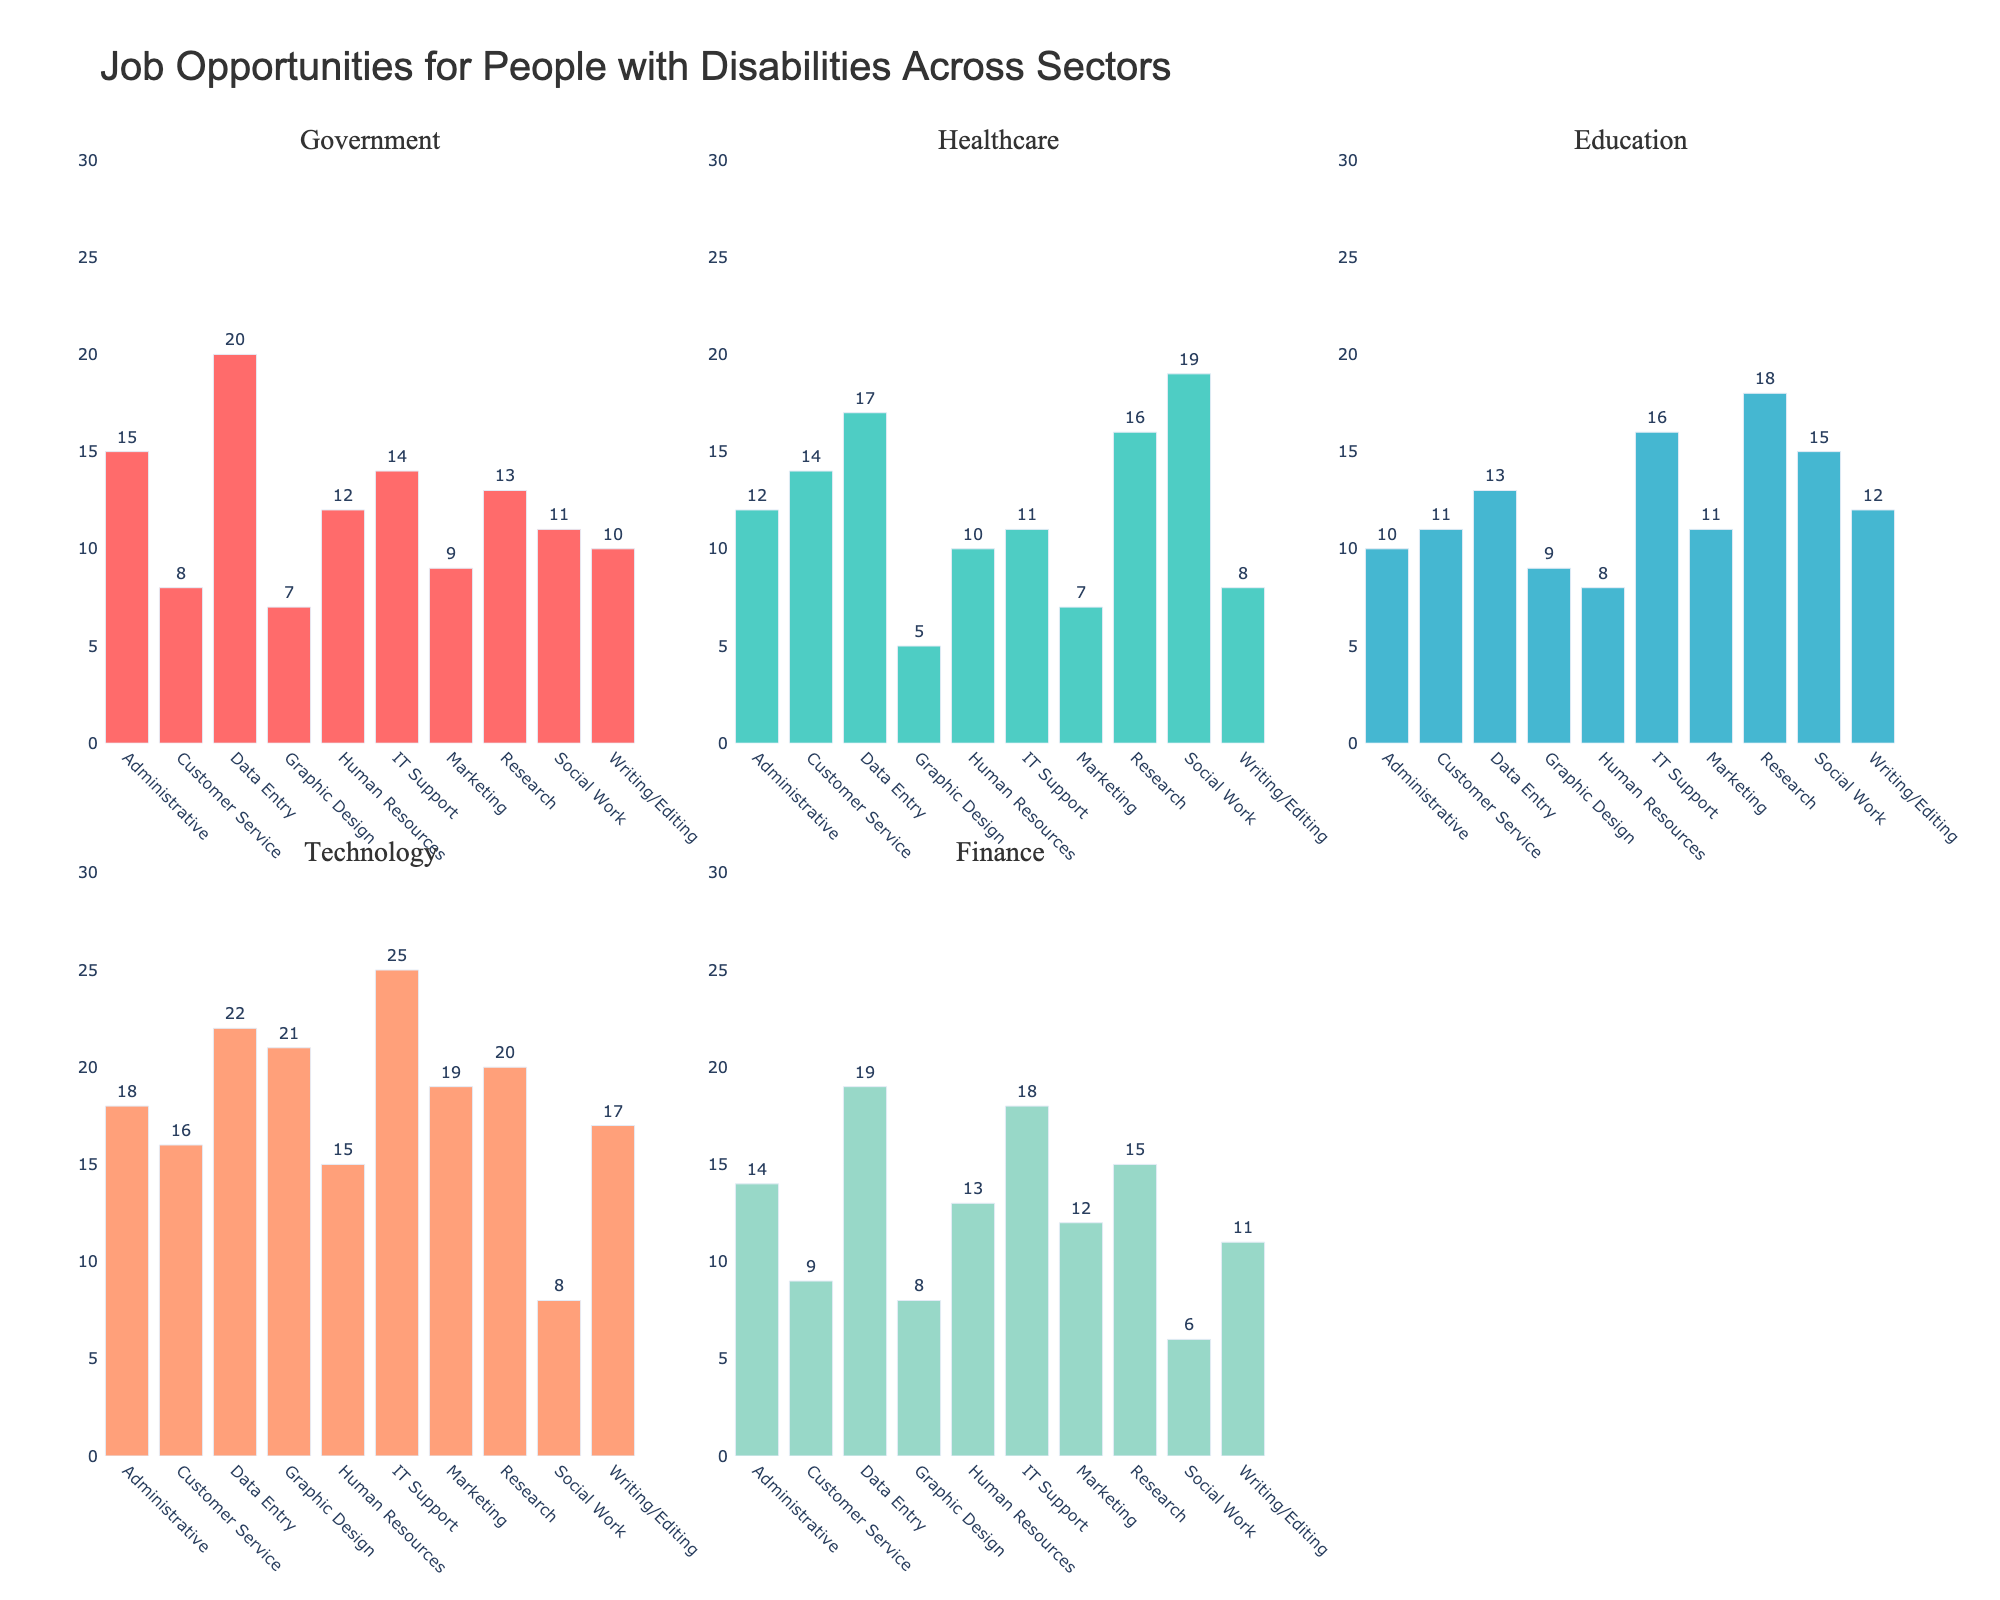What's the title of the figure? Look at the main title located at the top center of the figure; it describes the overall content.
Answer: Job Opportunities for People with Disabilities Across Sectors Which sector shows the highest number of job opportunities in the "Technology" sector? Refer to the tallest bar in the "Technology" sector subplot which indicates the job type with the highest number of opportunities.
Answer: IT Support How many job opportunities are there in the "Healthcare" sector for "Social Work"? Look at the "Healthcare" subplot and find the bar corresponding to "Social Work". The number at the top of the bar shows the value.
Answer: 19 Which job type provides more opportunities in the "Education" sector, "Marketing" or "Graphic Design"? Compare the height of the bars for "Marketing" and "Graphic Design" within the "Education" sector subplot.
Answer: Marketing What is the total number of job opportunities in the "Finance" sector? Sum up the values of all the bars under the "Finance" sector subplot: 14, 9, 19, 8, 13, 18, 12, 15, 6, 11. The total sum gives the answer.
Answer: 125 Identify the sector with the most varied (widest range) job opportunities. Compare the highest and lowest job opportunities within each sector by checking the tallest and shortest bars in each subplot. Identify the sector with the largest difference.
Answer: Technology Which job type in the "Government" sector has opportunities exceeding 15? Check the bars in the "Government" subplot and note down job types where the bar height exceeds the value 15.
Answer: Data Entry In which sector do "Writing/Editing" job opportunities have the lowest number? Compare the bar heights for "Writing/Editing" across all subplots and find the shortest one.
Answer: Healthcare What is the ratio of Data Entry opportunities in the "Technology" sector to the "Finance" sector? Look at the values corresponding to "Data Entry" in the "Technology" and "Finance" subplots, then compute and simplify the ratio 22:19.
Answer: 22:19 How does the number of "Customer Service" opportunities in the "Government" sector compare to the "Healthcare" sector? Compare the bar heights for "Customer Service" in both the "Government" and "Healthcare" subplots.
Answer: Government (8) is less than Healthcare (14) 